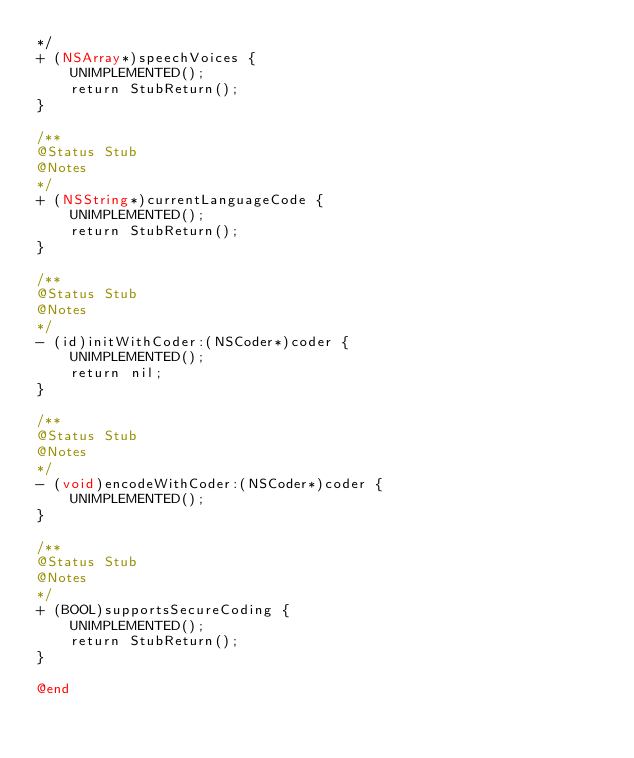Convert code to text. <code><loc_0><loc_0><loc_500><loc_500><_ObjectiveC_>*/
+ (NSArray*)speechVoices {
    UNIMPLEMENTED();
    return StubReturn();
}

/**
@Status Stub
@Notes
*/
+ (NSString*)currentLanguageCode {
    UNIMPLEMENTED();
    return StubReturn();
}

/**
@Status Stub
@Notes
*/
- (id)initWithCoder:(NSCoder*)coder {
    UNIMPLEMENTED();
    return nil;
}

/**
@Status Stub
@Notes
*/
- (void)encodeWithCoder:(NSCoder*)coder {
    UNIMPLEMENTED();
}

/**
@Status Stub
@Notes
*/
+ (BOOL)supportsSecureCoding {
    UNIMPLEMENTED();
    return StubReturn();
}

@end
</code> 